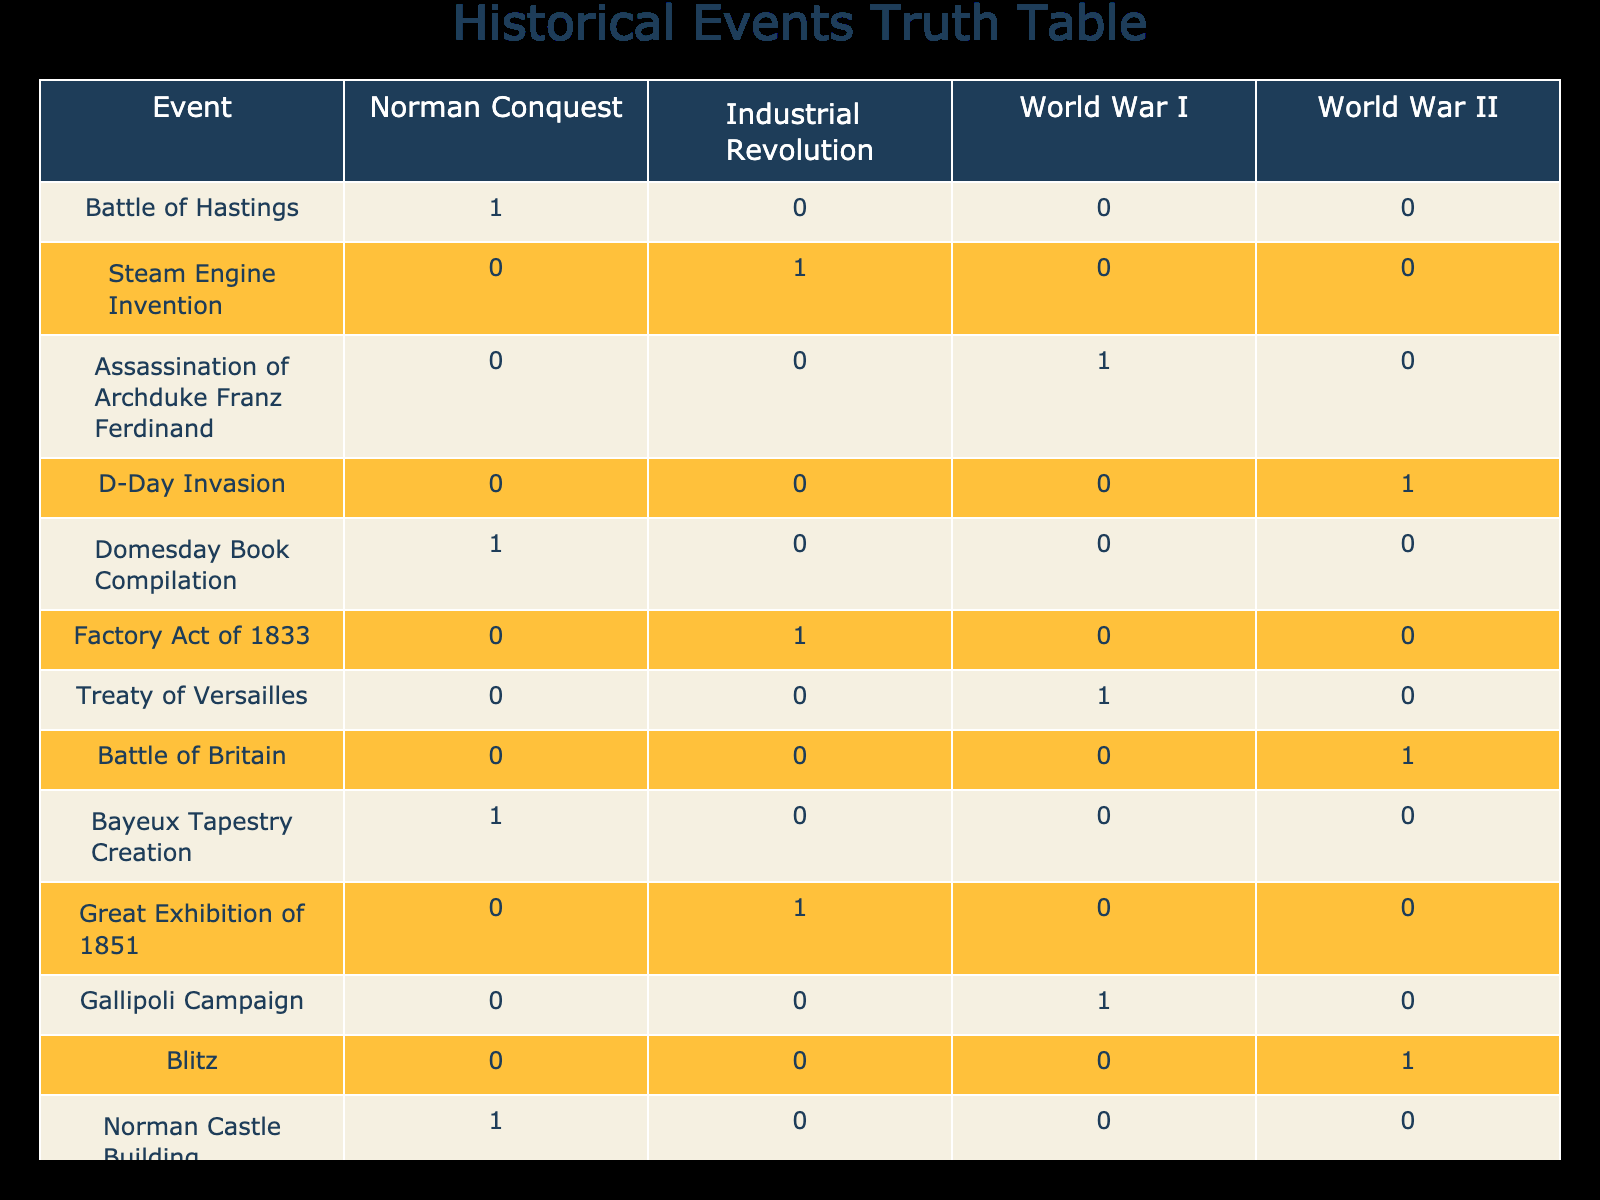What event is associated with the Industrial Revolution? The table indicates that the event related to the Industrial Revolution is the invention of the steam engine since it has a value of 1 under that column.
Answer: Steam Engine Invention Which events occurred during World War I? By checking the column for World War I, we see the events marked with a 1, which are the assassination of Archduke Franz Ferdinand, the Gallipoli Campaign, and the Battle of the Somme.
Answer: Assassination of Archduke Franz Ferdinand, Gallipoli Campaign, Battle of the Somme How many events happened before World War II? First, we count the events that have a value of 1 in the Norman Conquest and Industrial Revolution columns. We find 6 events: Battle of Hastings, D-Day Invasion, Domesday Book Compilation, Bayeux Tapestry Creation, Norman Castle Building, and others before World War II started.
Answer: 6 Was the Great Exhibition of 1851 related to any World War? To answer this, we look at the row for the Great Exhibition of 1851, which has a 0 under the World War columns, indicating that it is not related to either.
Answer: No Which historical events were associated with the Norman Conquest? We can determine the events linked to the Norman Conquest by inspecting the column and identifying the events marked with a 1. These are the Battle of Hastings, Domesday Book Compilation, Bayeux Tapestry Creation, and Norman Castle Building.
Answer: Battle of Hastings, Domesday Book Compilation, Bayeux Tapestry Creation, Norman Castle Building What is the total number of events listed in the table? The table contains 14 distinct historical events listed in the first column. By simply counting them, we find the total is 14 events.
Answer: 14 Which had more significant historical events: the Industrial Revolution or World War II? To determine this, we compare the number of events with a value of 1 in both the Industrial Revolution and World War II columns. The Industrial Revolution has 5 events, while World War II has 3. Thus, the Industrial Revolution had more significant historical events.
Answer: Industrial Revolution Did any event happen in both the Norman Conquest and the Industrial Revolution? By reviewing the corresponding rows in both columns, we see all have a value of 0 in the Industrial Revolution column while those in the Norman Conquest column marked with a 1 indicate they do not overlap.
Answer: No 